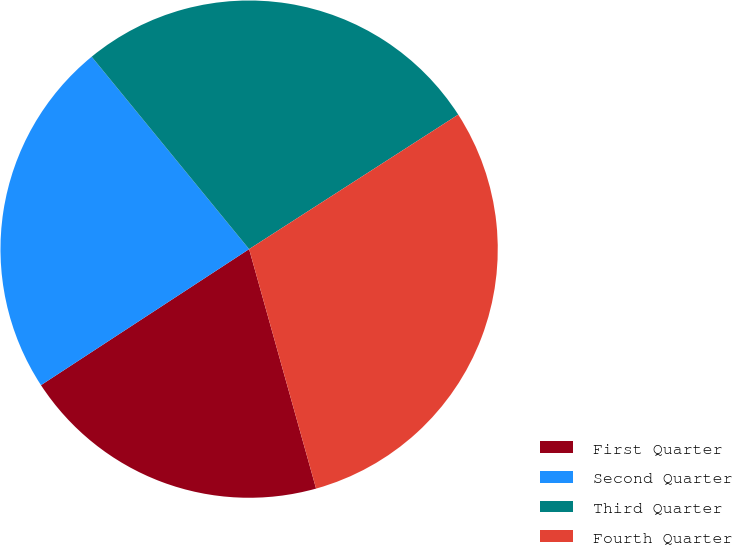<chart> <loc_0><loc_0><loc_500><loc_500><pie_chart><fcel>First Quarter<fcel>Second Quarter<fcel>Third Quarter<fcel>Fourth Quarter<nl><fcel>20.13%<fcel>23.3%<fcel>26.82%<fcel>29.76%<nl></chart> 